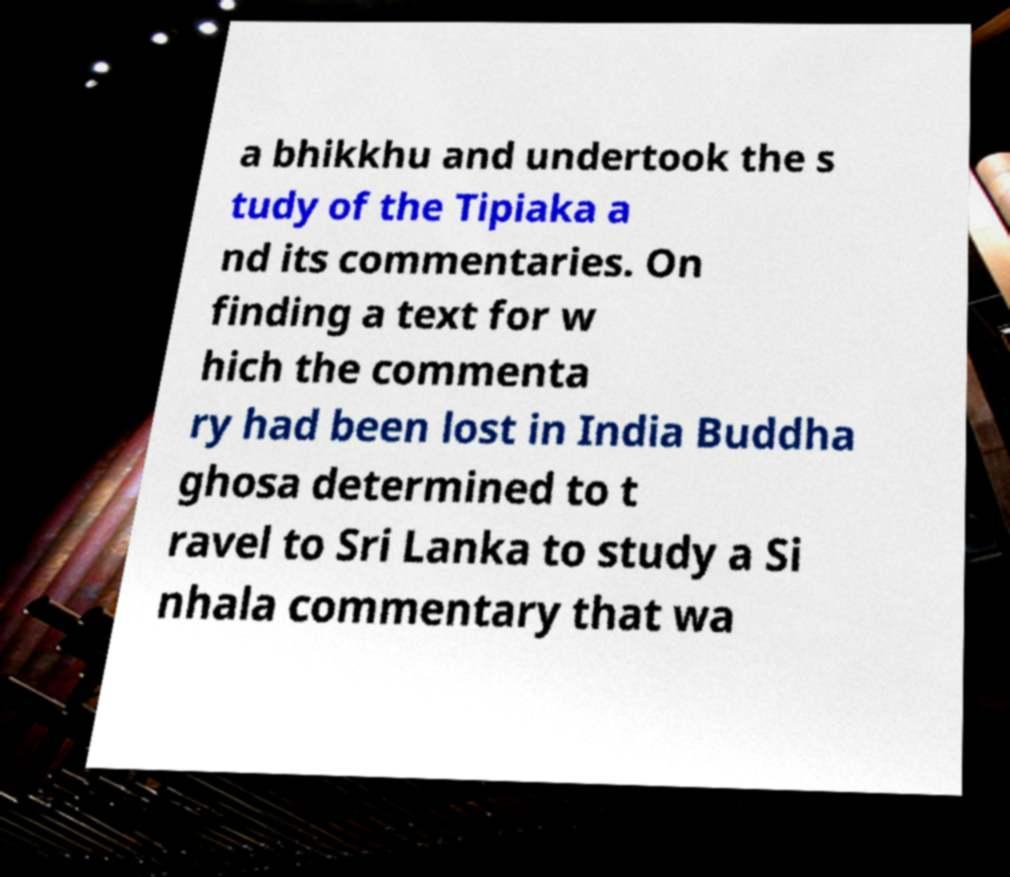Please read and relay the text visible in this image. What does it say? a bhikkhu and undertook the s tudy of the Tipiaka a nd its commentaries. On finding a text for w hich the commenta ry had been lost in India Buddha ghosa determined to t ravel to Sri Lanka to study a Si nhala commentary that wa 